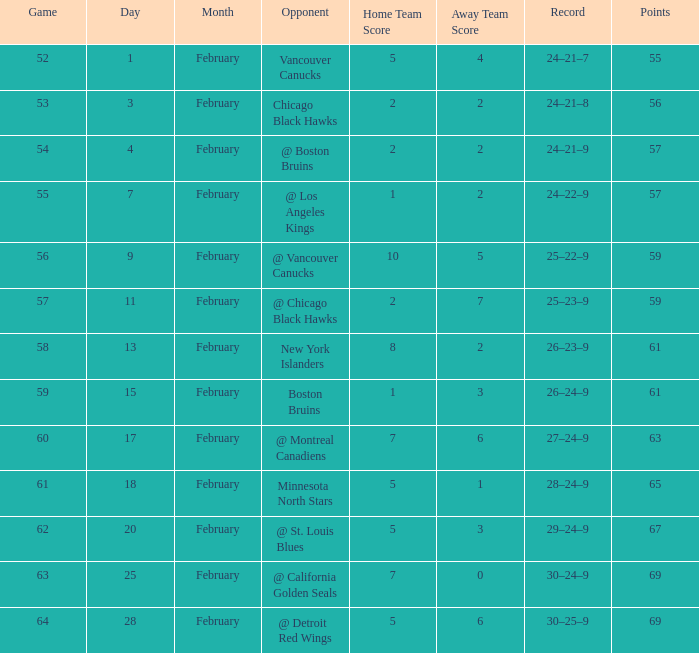How many games have a record of 30–25–9 and more points than 69? 0.0. 